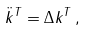<formula> <loc_0><loc_0><loc_500><loc_500>\ddot { k } ^ { T } = \Delta { k } ^ { T } \, ,</formula> 